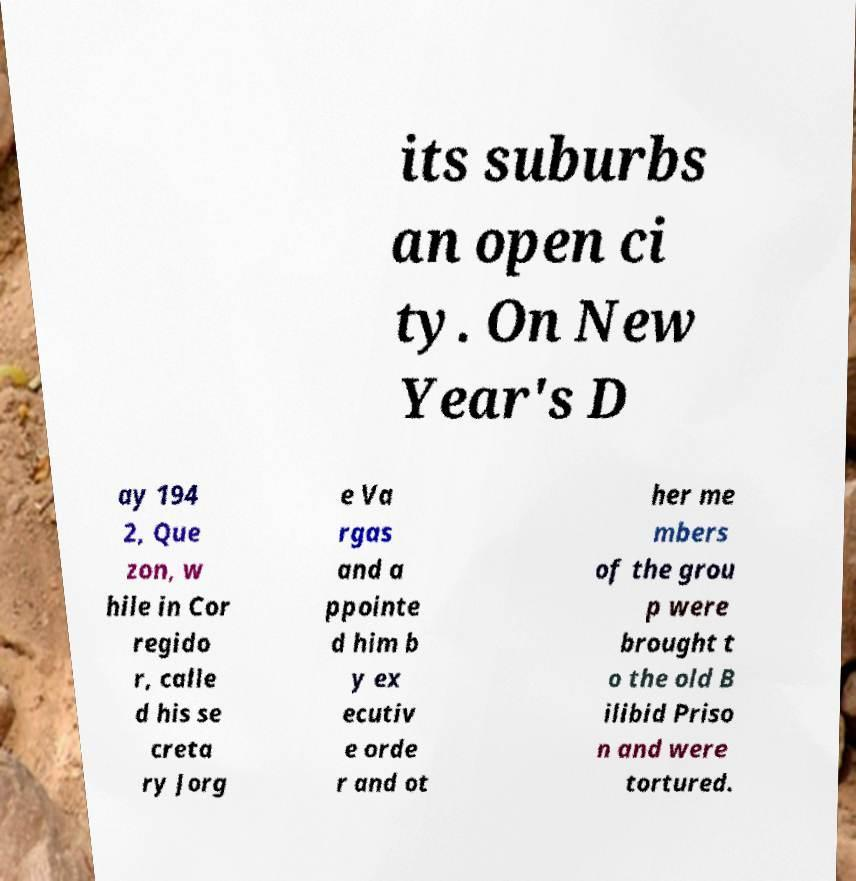Can you accurately transcribe the text from the provided image for me? its suburbs an open ci ty. On New Year's D ay 194 2, Que zon, w hile in Cor regido r, calle d his se creta ry Jorg e Va rgas and a ppointe d him b y ex ecutiv e orde r and ot her me mbers of the grou p were brought t o the old B ilibid Priso n and were tortured. 